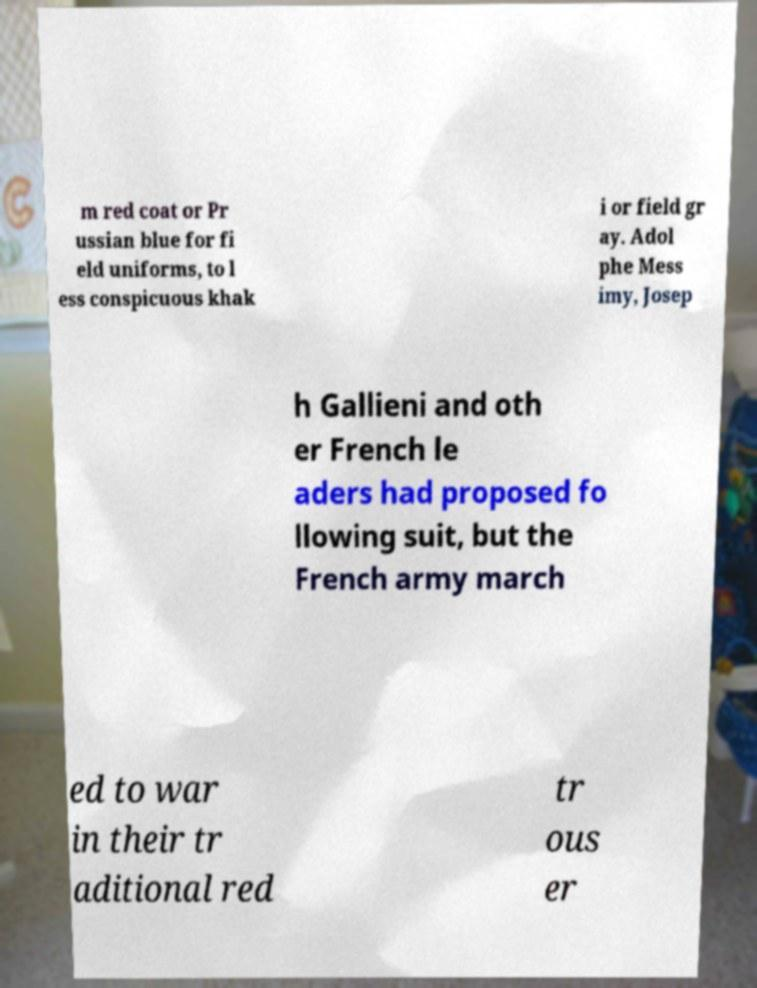Could you assist in decoding the text presented in this image and type it out clearly? m red coat or Pr ussian blue for fi eld uniforms, to l ess conspicuous khak i or field gr ay. Adol phe Mess imy, Josep h Gallieni and oth er French le aders had proposed fo llowing suit, but the French army march ed to war in their tr aditional red tr ous er 